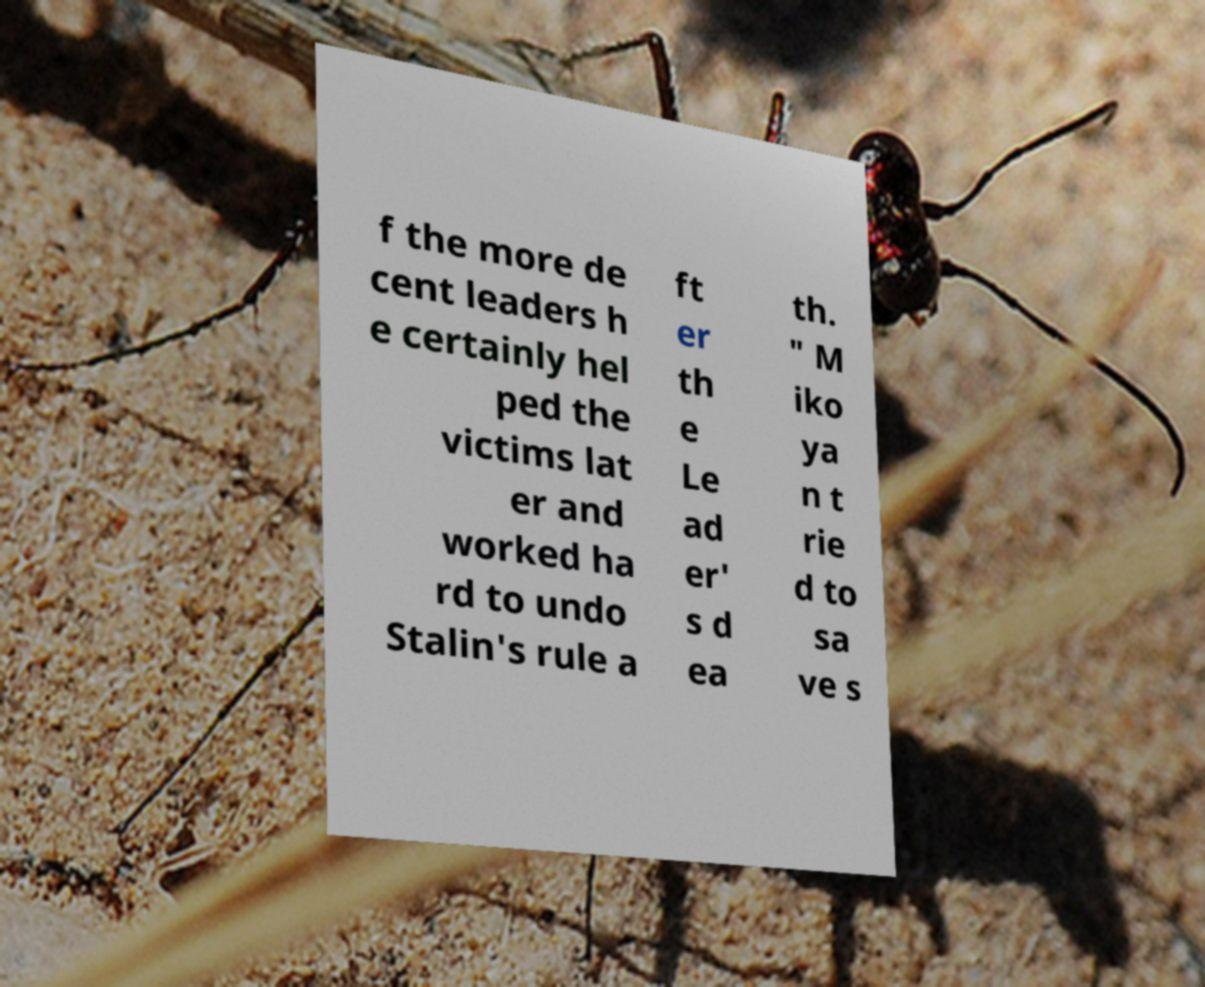What messages or text are displayed in this image? I need them in a readable, typed format. f the more de cent leaders h e certainly hel ped the victims lat er and worked ha rd to undo Stalin's rule a ft er th e Le ad er' s d ea th. " M iko ya n t rie d to sa ve s 